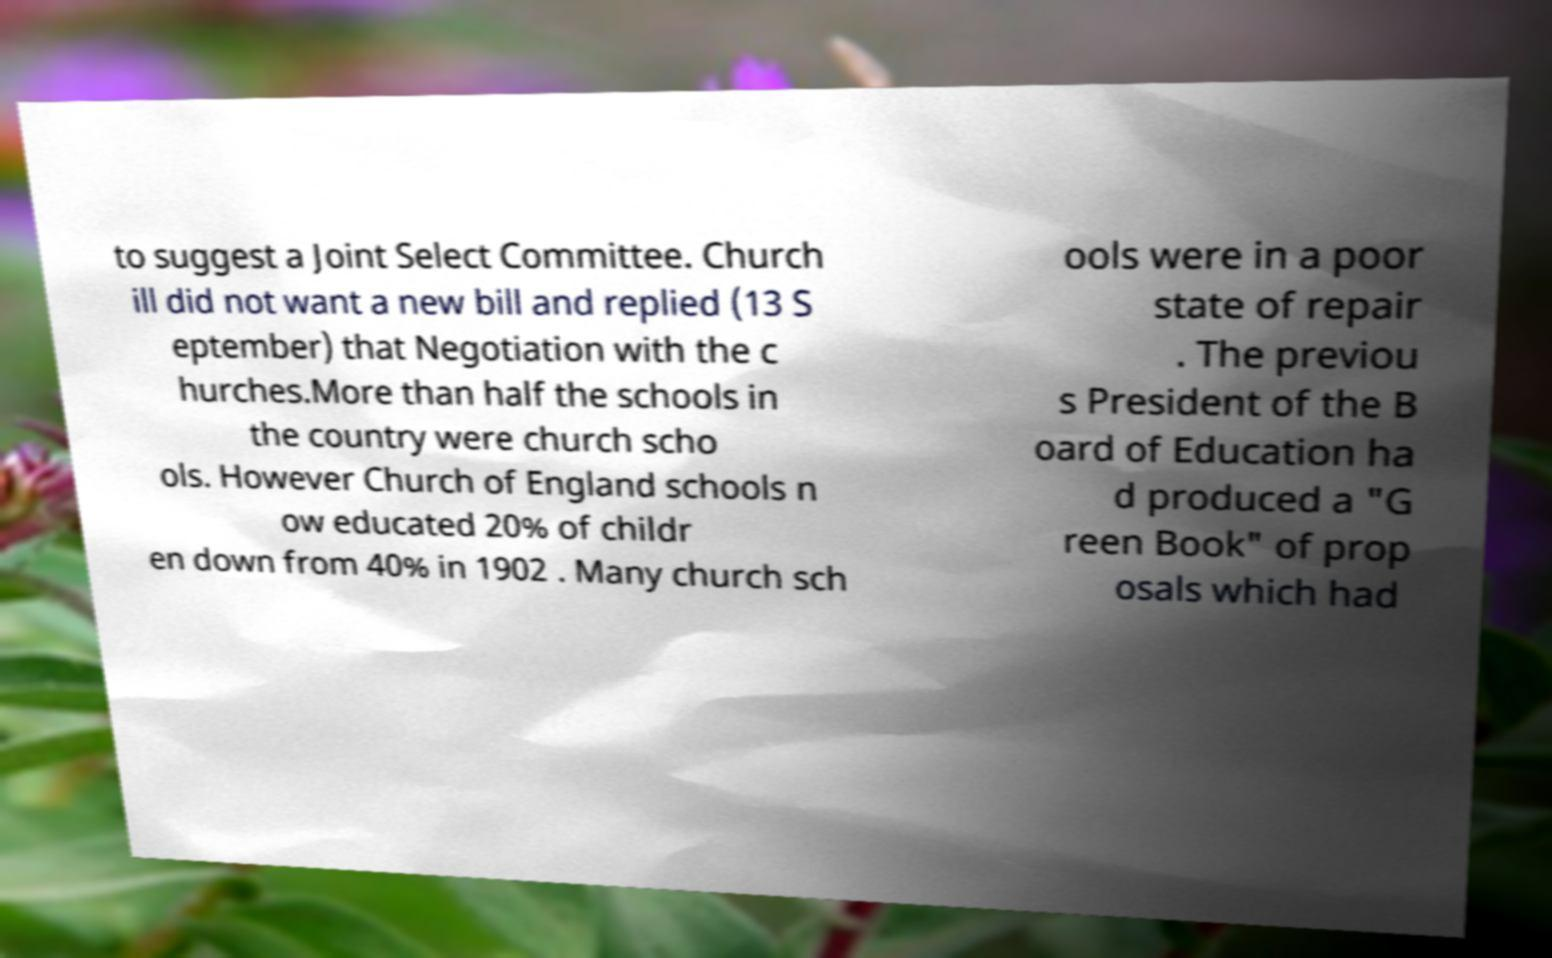Please identify and transcribe the text found in this image. to suggest a Joint Select Committee. Church ill did not want a new bill and replied (13 S eptember) that Negotiation with the c hurches.More than half the schools in the country were church scho ols. However Church of England schools n ow educated 20% of childr en down from 40% in 1902 . Many church sch ools were in a poor state of repair . The previou s President of the B oard of Education ha d produced a "G reen Book" of prop osals which had 